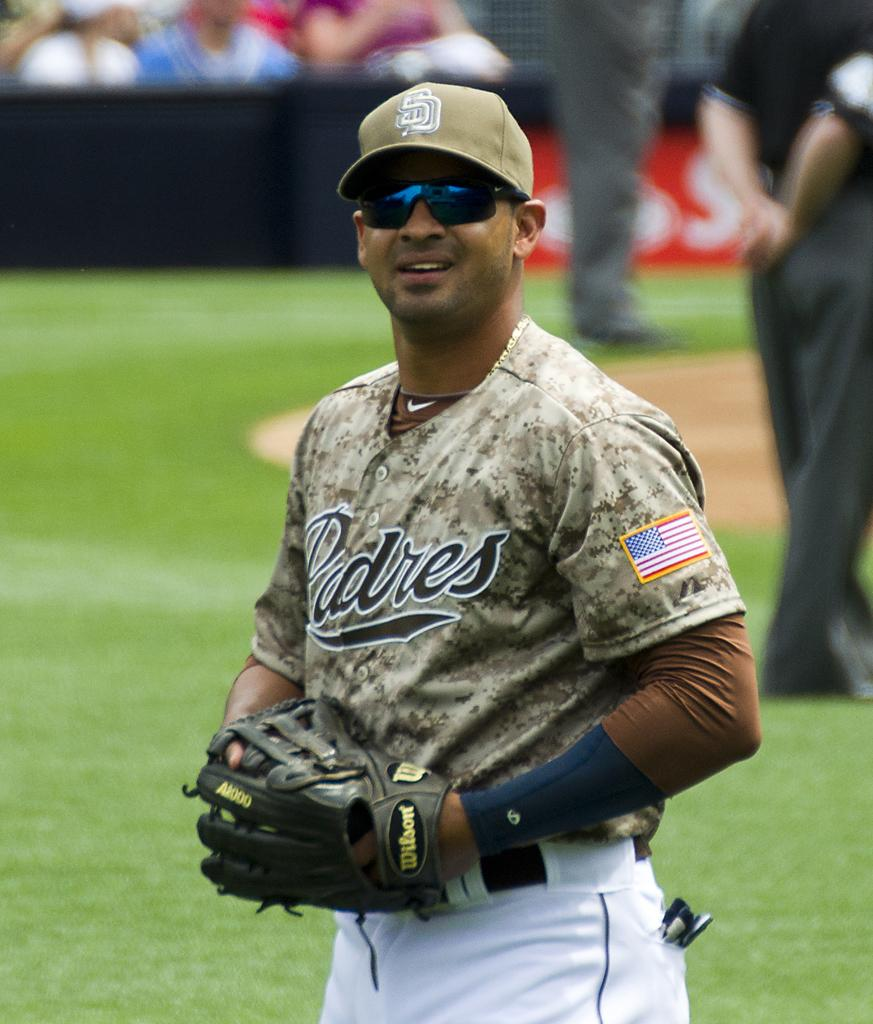<image>
Relay a brief, clear account of the picture shown. a person wearing a Padres uniform on a baseball field 